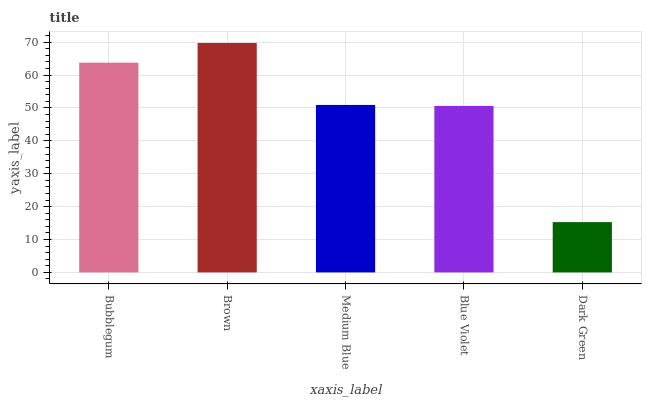Is Dark Green the minimum?
Answer yes or no. Yes. Is Brown the maximum?
Answer yes or no. Yes. Is Medium Blue the minimum?
Answer yes or no. No. Is Medium Blue the maximum?
Answer yes or no. No. Is Brown greater than Medium Blue?
Answer yes or no. Yes. Is Medium Blue less than Brown?
Answer yes or no. Yes. Is Medium Blue greater than Brown?
Answer yes or no. No. Is Brown less than Medium Blue?
Answer yes or no. No. Is Medium Blue the high median?
Answer yes or no. Yes. Is Medium Blue the low median?
Answer yes or no. Yes. Is Bubblegum the high median?
Answer yes or no. No. Is Bubblegum the low median?
Answer yes or no. No. 